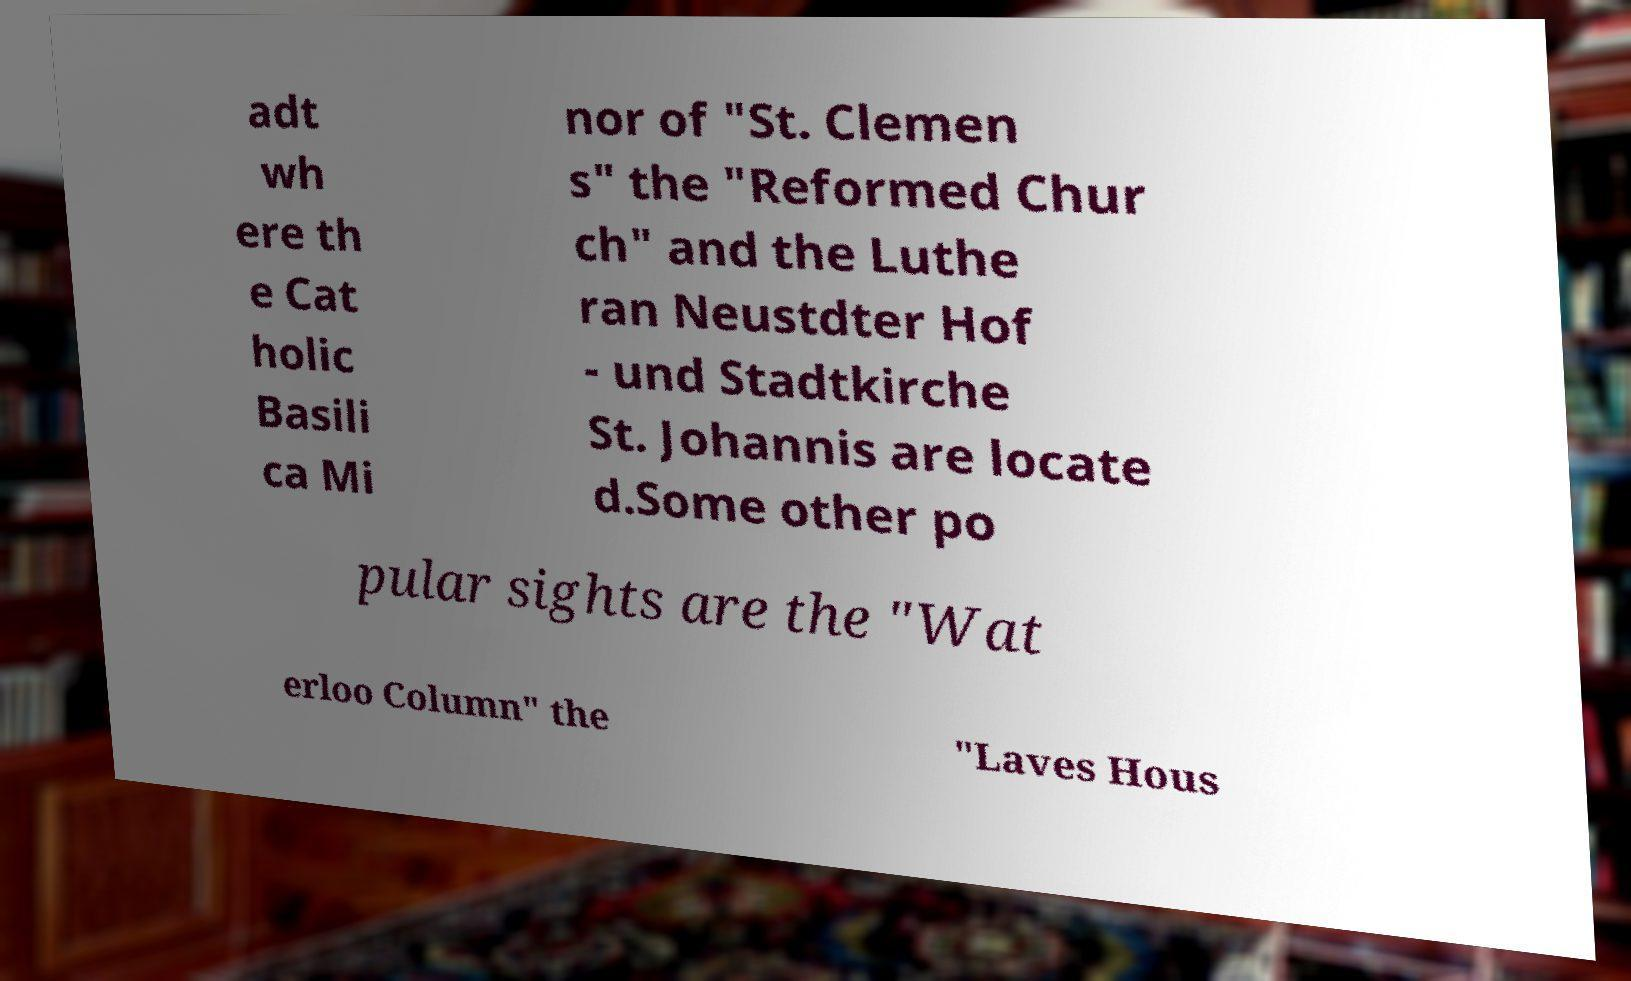Could you extract and type out the text from this image? adt wh ere th e Cat holic Basili ca Mi nor of "St. Clemen s" the "Reformed Chur ch" and the Luthe ran Neustdter Hof - und Stadtkirche St. Johannis are locate d.Some other po pular sights are the "Wat erloo Column" the "Laves Hous 